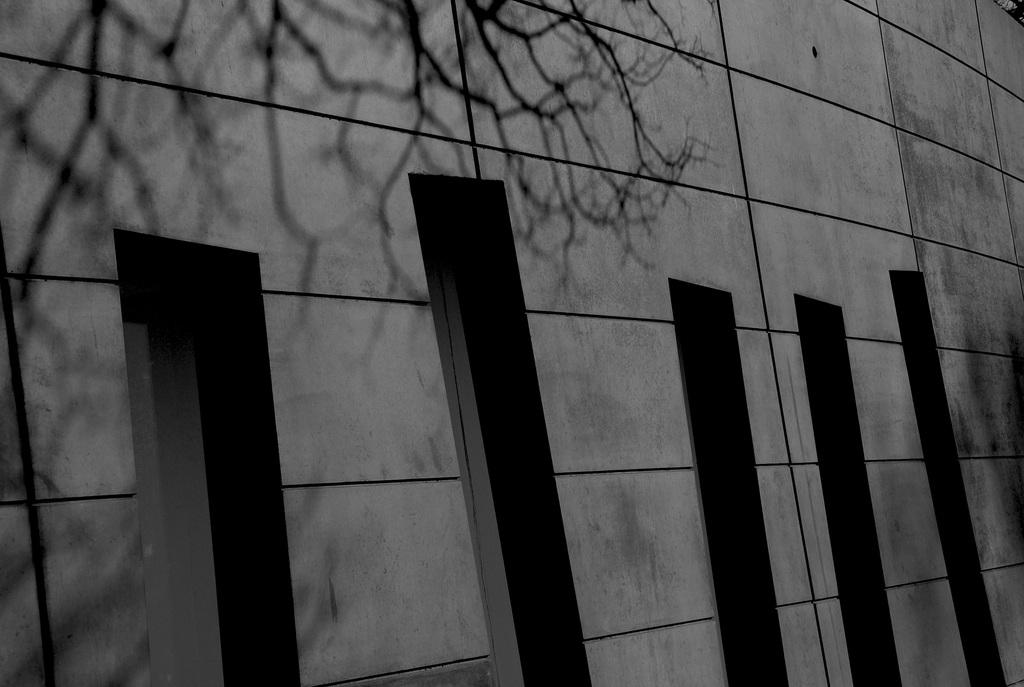What is the main feature in the image? There is a wall in the image. What type of reward is being given to the students in the class in the image? There is no mention of students, a class, or a reward in the image; it only features a wall. 